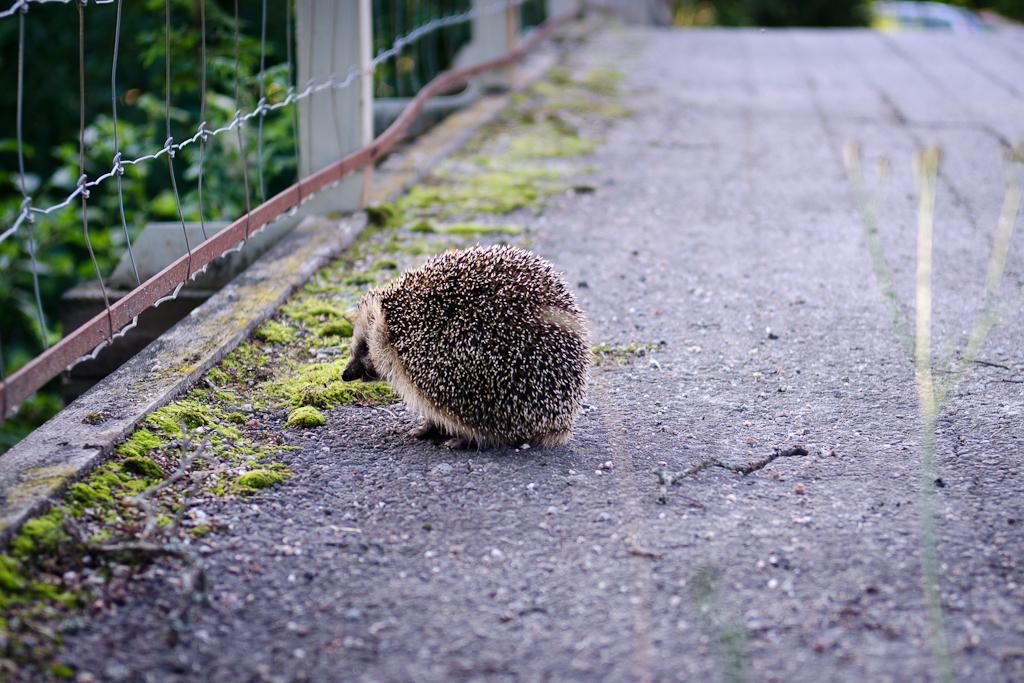How would you summarize this image in a sentence or two? In this image we can see one animal on the road and so many trees. Some grass is there. One fence attached to the three poles. 